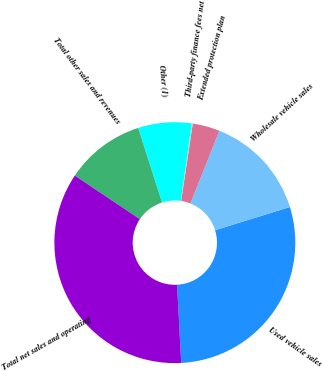Convert chart to OTSL. <chart><loc_0><loc_0><loc_500><loc_500><pie_chart><fcel>Used vehicle sales<fcel>Wholesale vehicle sales<fcel>Extended protection plan<fcel>Third-party finance fees net<fcel>Other (1)<fcel>Total other sales and revenues<fcel>Total net sales and operating<nl><fcel>28.94%<fcel>14.18%<fcel>3.65%<fcel>0.14%<fcel>7.16%<fcel>10.67%<fcel>35.24%<nl></chart> 